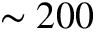Convert formula to latex. <formula><loc_0><loc_0><loc_500><loc_500>\sim 2 0 0</formula> 